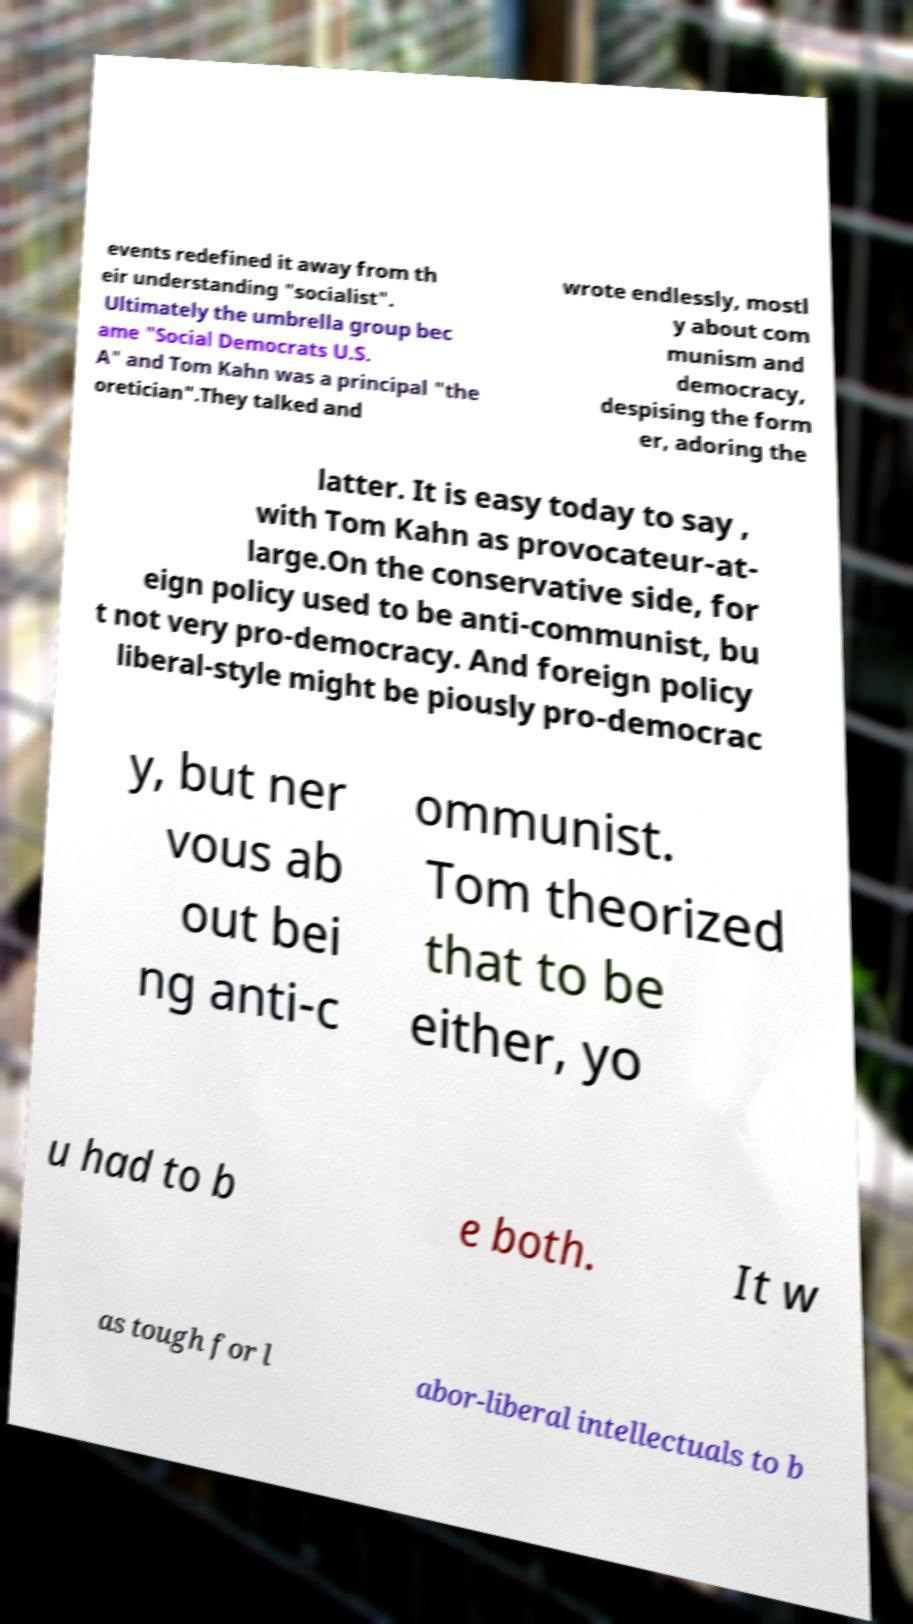There's text embedded in this image that I need extracted. Can you transcribe it verbatim? events redefined it away from th eir understanding "socialist". Ultimately the umbrella group bec ame "Social Democrats U.S. A" and Tom Kahn was a principal "the oretician".They talked and wrote endlessly, mostl y about com munism and democracy, despising the form er, adoring the latter. It is easy today to say , with Tom Kahn as provocateur-at- large.On the conservative side, for eign policy used to be anti-communist, bu t not very pro-democracy. And foreign policy liberal-style might be piously pro-democrac y, but ner vous ab out bei ng anti-c ommunist. Tom theorized that to be either, yo u had to b e both. It w as tough for l abor-liberal intellectuals to b 